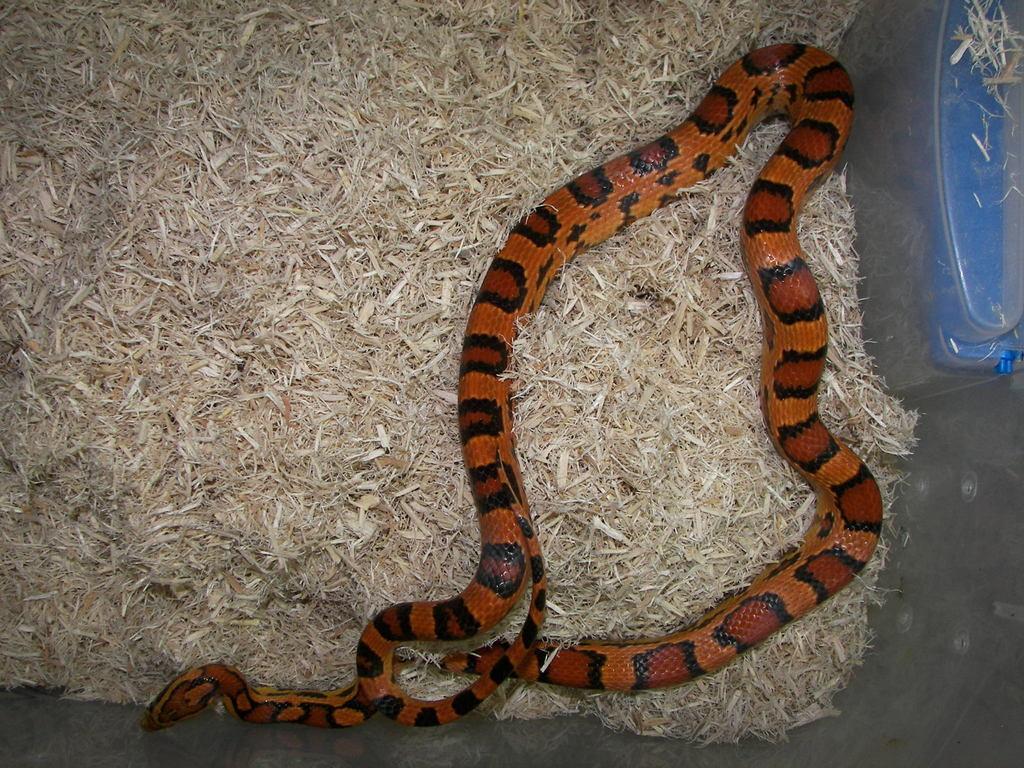What type of animal can be seen in the grass in the image? There is a snake in the grass in the image. Can you describe the object that is truncated towards the right side of the image? Unfortunately, the provided facts do not give enough information to describe the truncated object. What type of oatmeal is being transported for digestion in the image? There is no oatmeal, transportation, or digestion depicted in the image. 